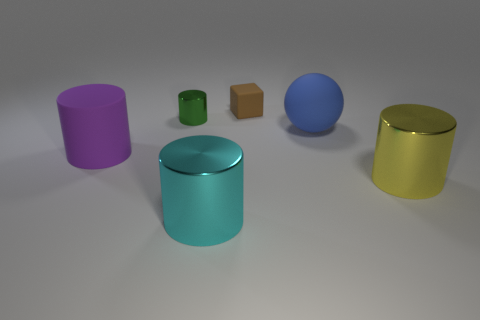Add 4 large blue rubber objects. How many objects exist? 10 Subtract all cubes. How many objects are left? 5 Add 3 cyan metallic cylinders. How many cyan metallic cylinders are left? 4 Add 2 cyan cylinders. How many cyan cylinders exist? 3 Subtract 0 blue blocks. How many objects are left? 6 Subtract all cyan objects. Subtract all small cylinders. How many objects are left? 4 